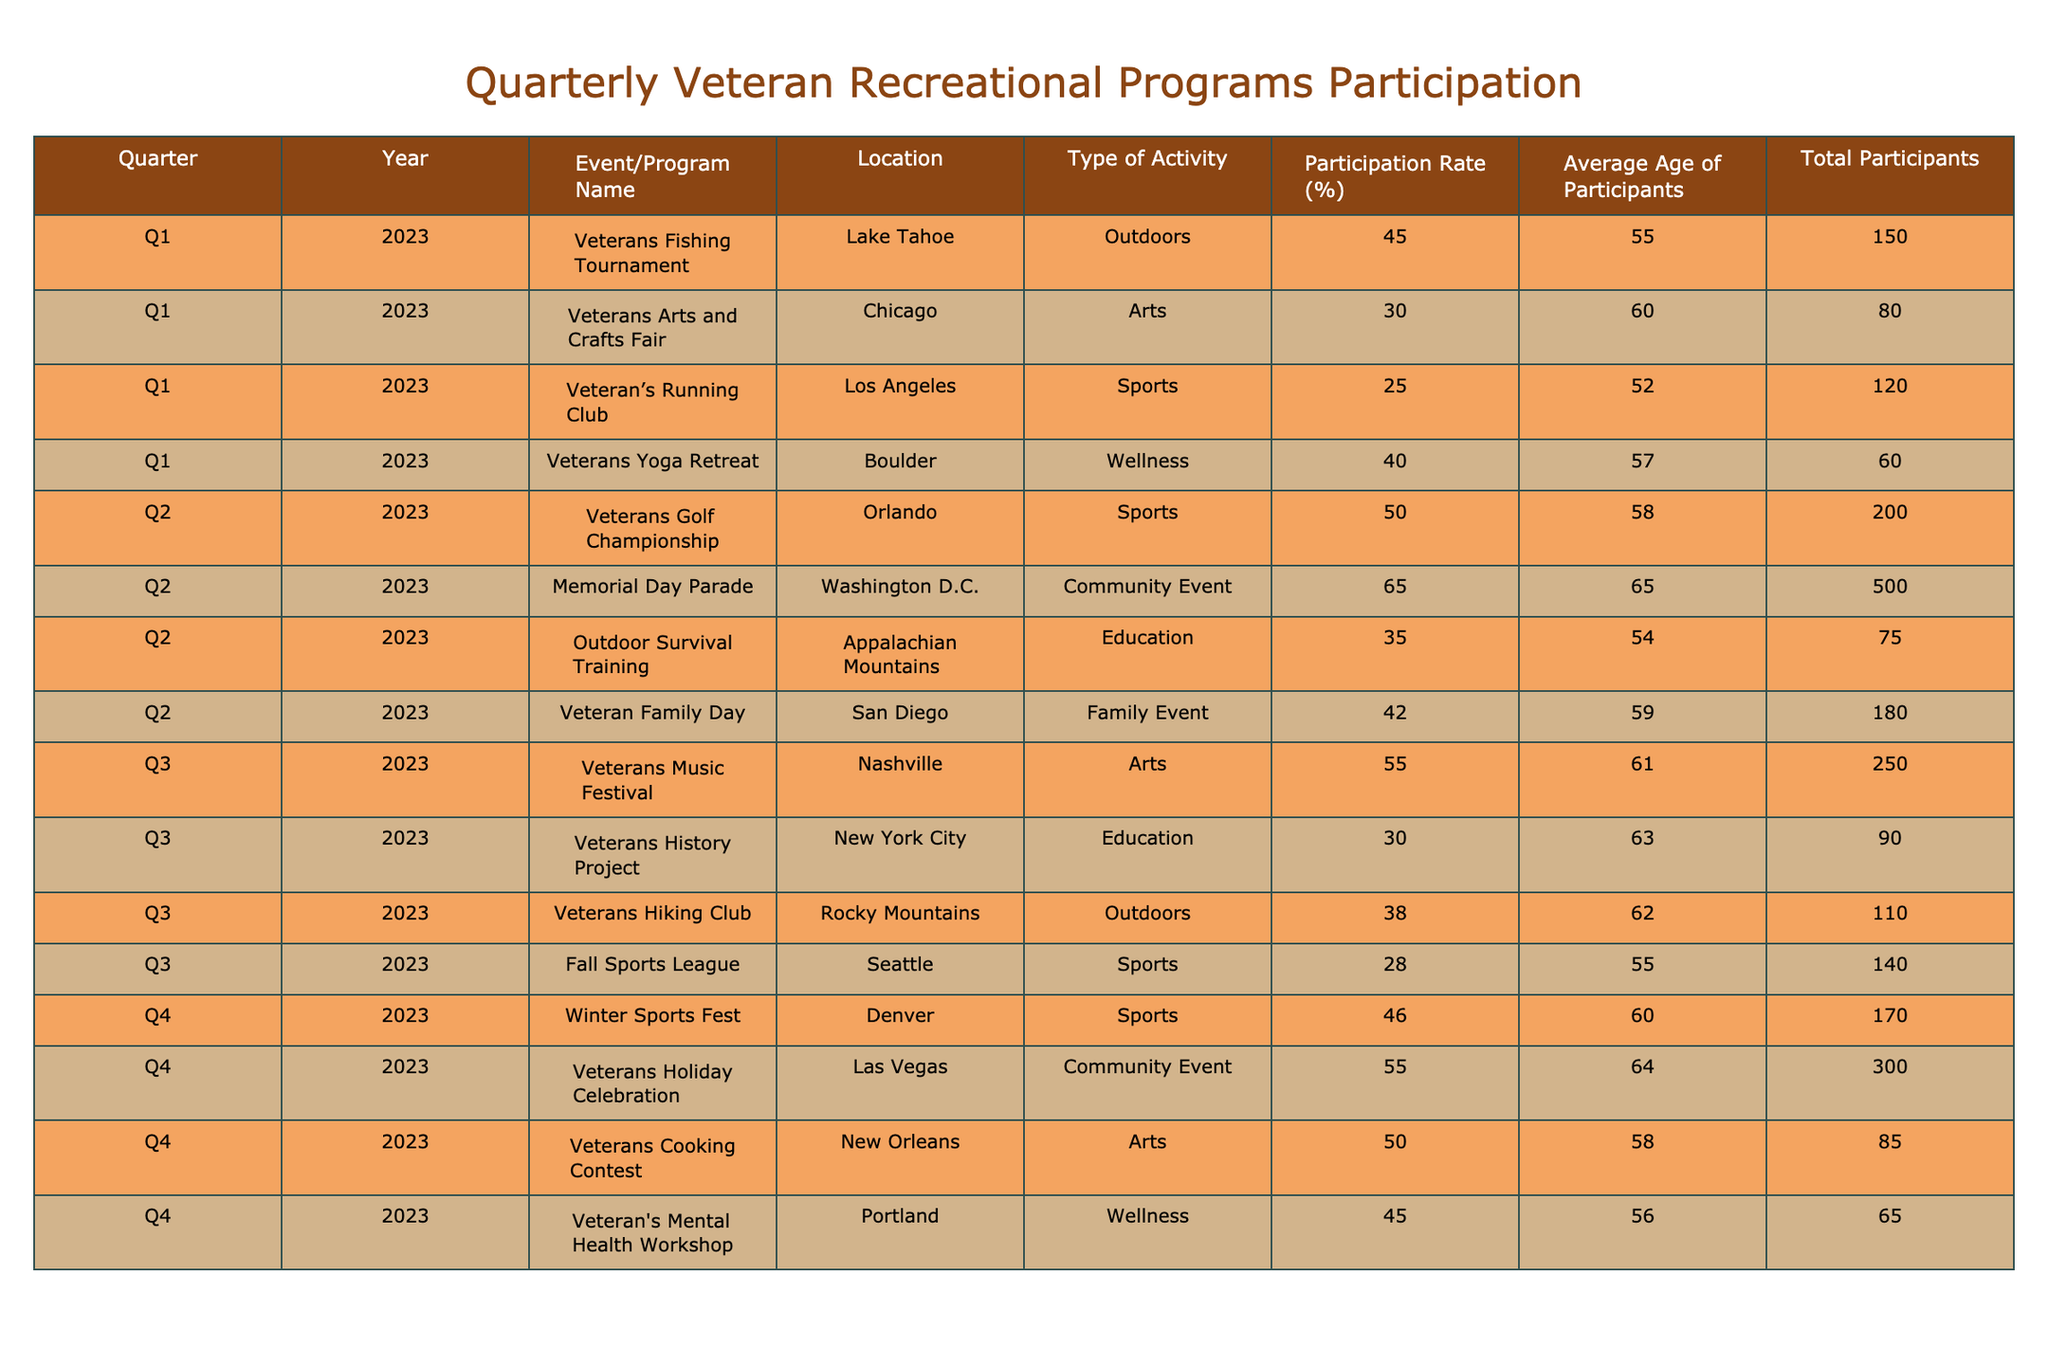What is the participation rate for the Veterans Fishing Tournament? The participation rate for the Veterans Fishing Tournament in Q1 2023 is listed directly in the table as 45.0%.
Answer: 45.0% What event had the highest participation rate in Q2 2023? In Q2 2023, the Memorial Day Parade had the highest participation rate at 65.0%, as shown in the table.
Answer: 65.0% How many total participants attended the Veterans Arts and Crafts Fair? Referring to the table, the total number of participants at the Veterans Arts and Crafts Fair is 80.
Answer: 80 What is the average age of participants in the Veteran’s Running Club? The average age of participants in the Veteran’s Running Club, as per the table, is 52 years old.
Answer: 52 What is the overall average participation rate for all programs in Q3 2023? To calculate the average participation rate for Q3 2023, sum the participation rates (55.0 + 30.0 + 38.0 + 28.0 = 151.0) and divide by the number of events (4), yielding an average of 37.75%.
Answer: 37.75% Did more than 200 participants attend any event in Q1 2023? By checking the total participants in Q1 2023, only the Veterans Fishing Tournament, Veterans Arts and Crafts Fair, Veteran’s Running Club, and Veterans Yoga Retreat showed total participants under or equal to 200. Therefore, the answer is no.
Answer: No Which program in Q4 2023 had the lowest average age of participants? Upon examining the table, the Veterans Cooking Contest had participants with the lowest average age of 58, whereas others had ages 56 and above, indicating it is the lowest.
Answer: 58 What was the difference in participation rate between the Veterans Golf Championship and the Veterans Family Day? The participation rate for the Veterans Golf Championship is 50.0% and for the Veterans Family Day is 42.0%. Thus, the difference is 50.0 - 42.0 = 8.0%.
Answer: 8.0% Which quarter had a higher participation rate: Q2 or Q4 2023? The average participation rates for Q2 and Q4 can be calculated (Q2 rates: 50.0, 65.0, 35.0, 42.0 average = 48.0%; Q4 rates: 46.0, 55.0, 50.0, 45.0 average = 49.0%). Comparing these values shows Q4 had a higher average participation rate.
Answer: Q4 Is the participation rate for the Outdoor Survival Training above the average participation rate of Q1 2023? The participation rate for the Outdoor Survival Training is 35.0%. The average participation rate for Q1 2023 can be found by summing the rates (45.0 + 30.0 + 25.0 + 40.0 = 140.0) and dividing by 4, giving an average of 35.0%. Thus, it is not above the average.
Answer: No 